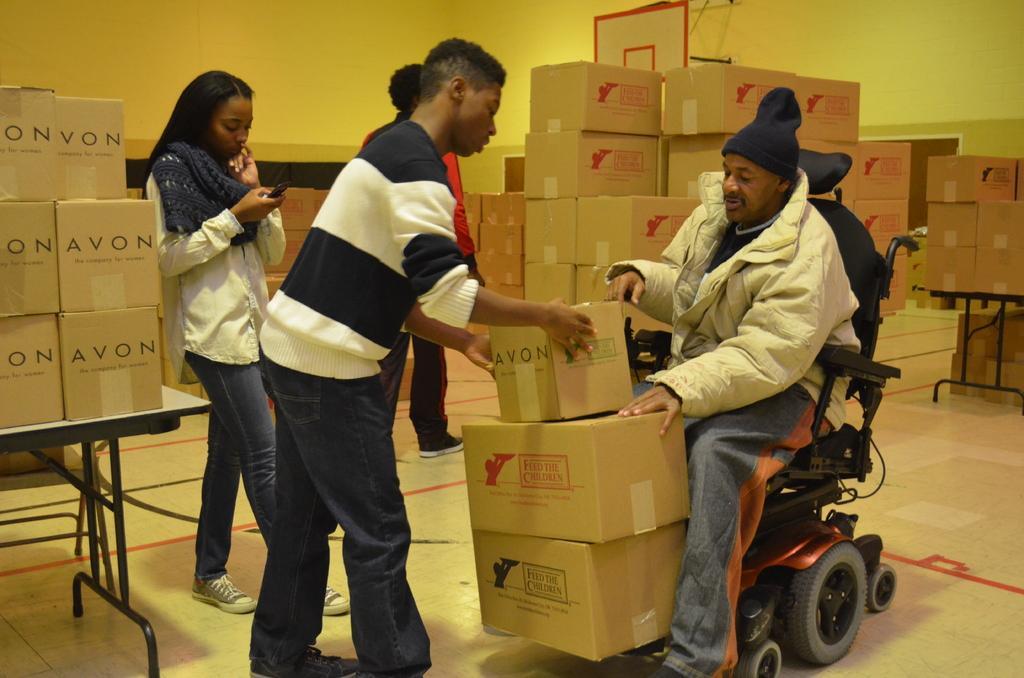Describe this image in one or two sentences. In this image we can see some group of persons standing and a person sitting on the wheelchair carrying some cardboard boxes and in the background of the image there are some cardboard boxes which are arranged and there is a wall. 